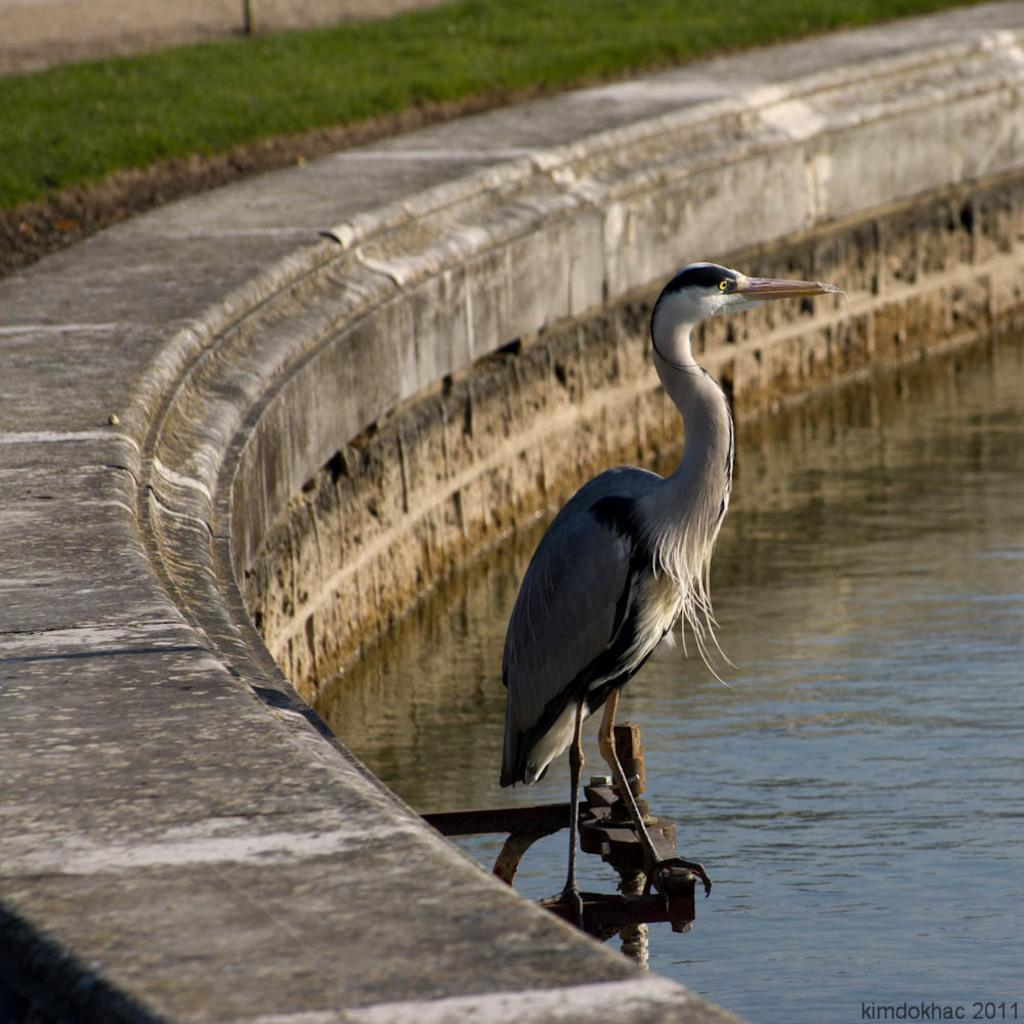What type of animal can be seen in the image? There is a bird in the image. Where is the bird located? The bird is on an object in the image. What natural elements are visible in the image? Water and grass are visible in the image. What man-made structure is present in the image? There is a wall in the image. Is there any text included in the image? Yes, there is text at the bottom of the image. What type of wood is the bird using to express its interest in the caption? There is no wood or caption present in the image, and the bird is not expressing any interest. 